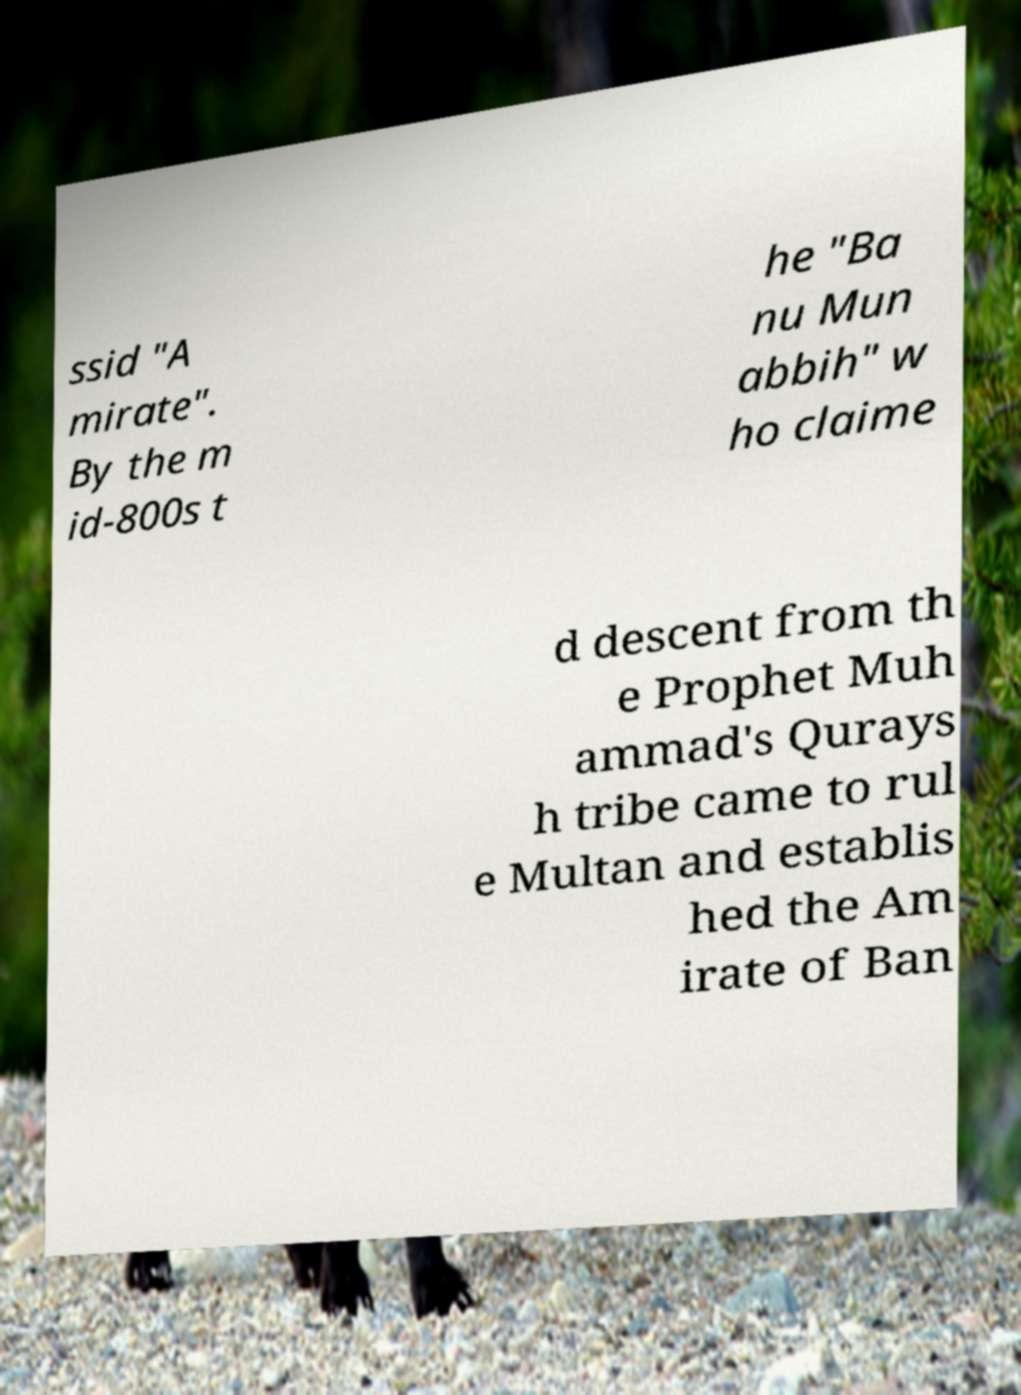Could you extract and type out the text from this image? ssid "A mirate". By the m id-800s t he "Ba nu Mun abbih" w ho claime d descent from th e Prophet Muh ammad's Qurays h tribe came to rul e Multan and establis hed the Am irate of Ban 